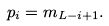<formula> <loc_0><loc_0><loc_500><loc_500>p _ { i } = m _ { L - i + 1 } .</formula> 